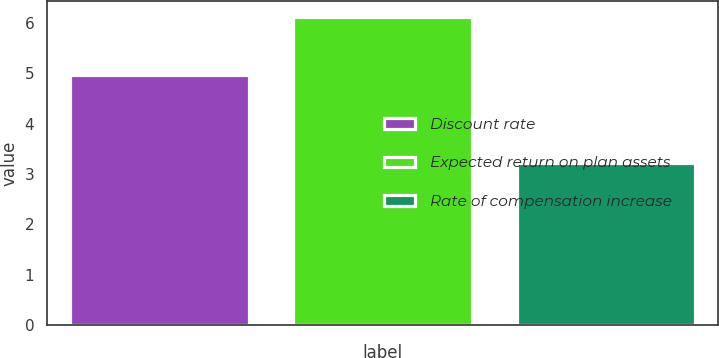Convert chart. <chart><loc_0><loc_0><loc_500><loc_500><bar_chart><fcel>Discount rate<fcel>Expected return on plan assets<fcel>Rate of compensation increase<nl><fcel>4.96<fcel>6.12<fcel>3.21<nl></chart> 